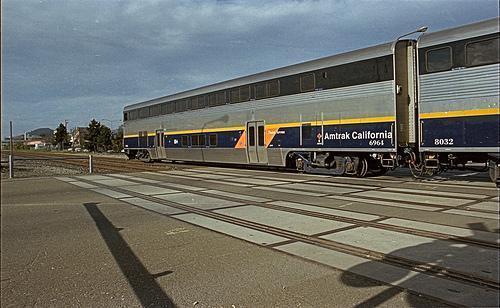How many trains are there?
Give a very brief answer. 1. 